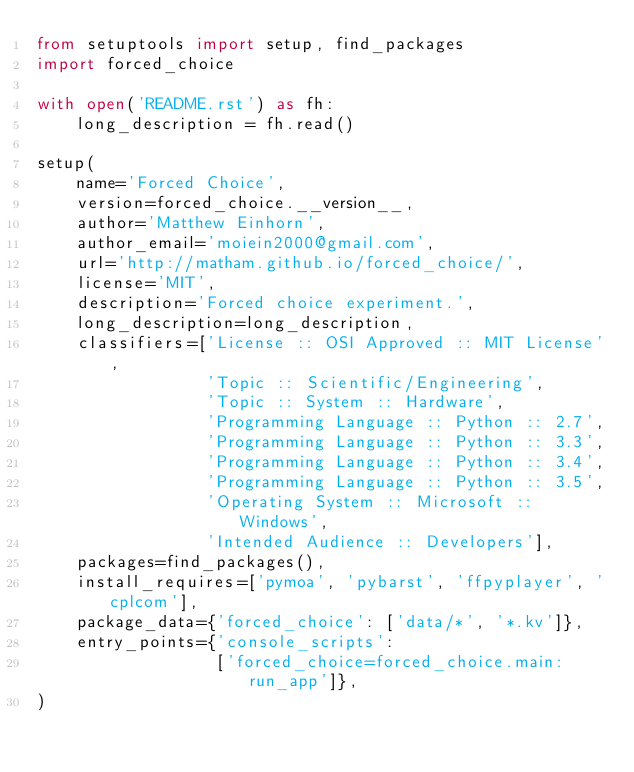<code> <loc_0><loc_0><loc_500><loc_500><_Python_>from setuptools import setup, find_packages
import forced_choice

with open('README.rst') as fh:
    long_description = fh.read()

setup(
    name='Forced Choice',
    version=forced_choice.__version__,
    author='Matthew Einhorn',
    author_email='moiein2000@gmail.com',
    url='http://matham.github.io/forced_choice/',
    license='MIT',
    description='Forced choice experiment.',
    long_description=long_description,
    classifiers=['License :: OSI Approved :: MIT License',
                 'Topic :: Scientific/Engineering',
                 'Topic :: System :: Hardware',
                 'Programming Language :: Python :: 2.7',
                 'Programming Language :: Python :: 3.3',
                 'Programming Language :: Python :: 3.4',
                 'Programming Language :: Python :: 3.5',
                 'Operating System :: Microsoft :: Windows',
                 'Intended Audience :: Developers'],
    packages=find_packages(),
    install_requires=['pymoa', 'pybarst', 'ffpyplayer', 'cplcom'],
    package_data={'forced_choice': ['data/*', '*.kv']},
    entry_points={'console_scripts':
                  ['forced_choice=forced_choice.main:run_app']},
)
</code> 